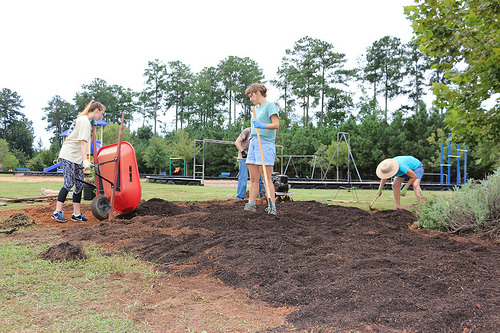<image>
Is there a wheelbarrow under the tree? No. The wheelbarrow is not positioned under the tree. The vertical relationship between these objects is different. Where is the sky in relation to the park? Is it in front of the park? No. The sky is not in front of the park. The spatial positioning shows a different relationship between these objects. Is there a cap above the soil? Yes. The cap is positioned above the soil in the vertical space, higher up in the scene. Is there a girl above the mound? No. The girl is not positioned above the mound. The vertical arrangement shows a different relationship. 